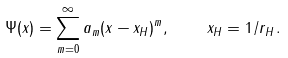Convert formula to latex. <formula><loc_0><loc_0><loc_500><loc_500>\Psi ( x ) = \sum _ { m = 0 } ^ { \infty } a _ { m } ( x - x _ { H } ) ^ { m } , \quad x _ { H } = 1 / r _ { H } \, .</formula> 